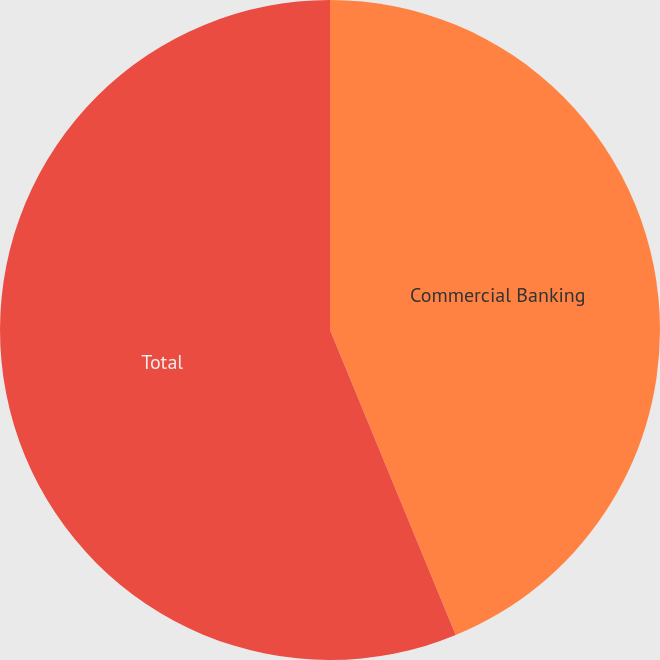Convert chart. <chart><loc_0><loc_0><loc_500><loc_500><pie_chart><fcel>Commercial Banking<fcel>Total<nl><fcel>43.78%<fcel>56.22%<nl></chart> 